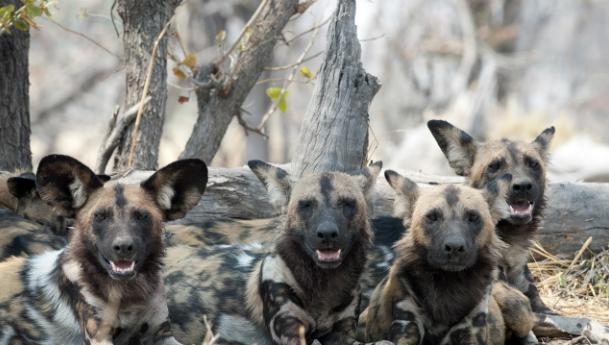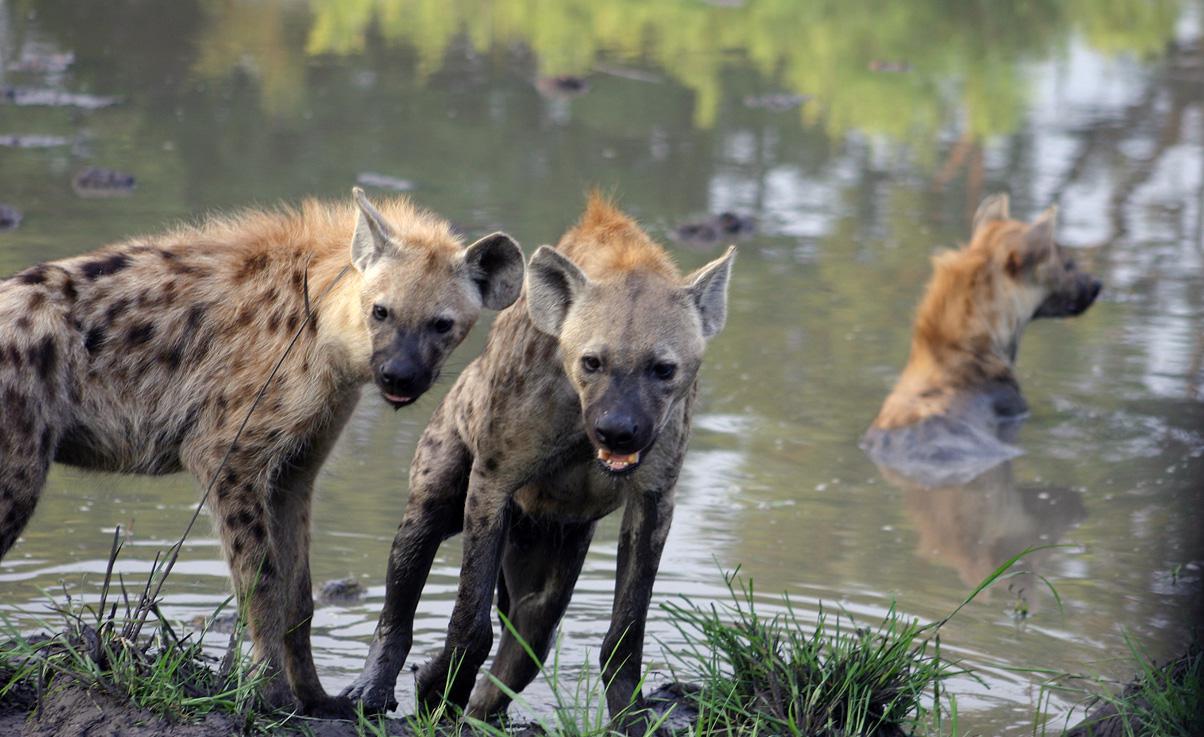The first image is the image on the left, the second image is the image on the right. Given the left and right images, does the statement "Some of the animals are eating their prey." hold true? Answer yes or no. No. The first image is the image on the left, the second image is the image on the right. Examine the images to the left and right. Is the description "At least one of the images shows hyenas eating a carcass." accurate? Answer yes or no. No. 